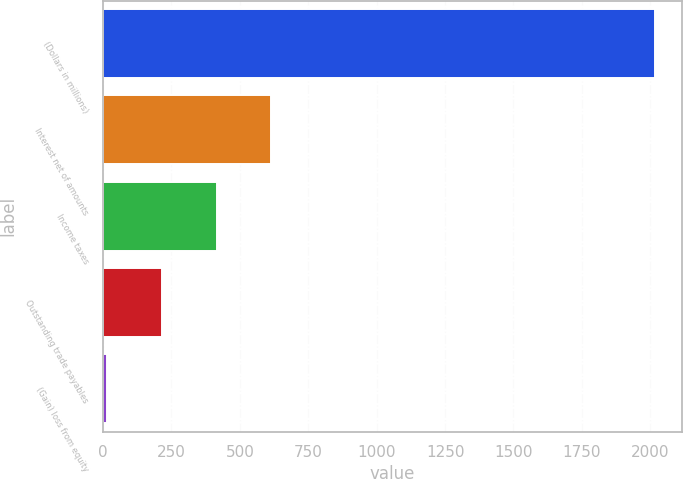Convert chart. <chart><loc_0><loc_0><loc_500><loc_500><bar_chart><fcel>(Dollars in millions)<fcel>Interest net of amounts<fcel>Income taxes<fcel>Outstanding trade payables<fcel>(Gain) loss from equity<nl><fcel>2016<fcel>615.3<fcel>415.2<fcel>215.1<fcel>15<nl></chart> 